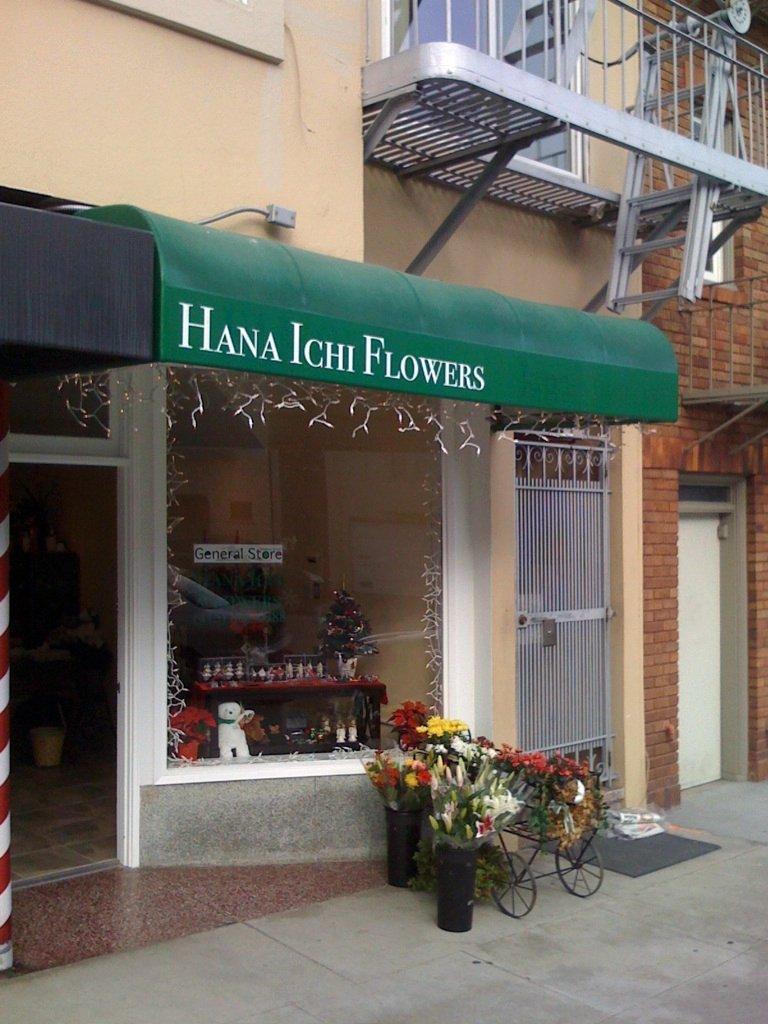Describe this image in one or two sentences. There are flower vases, which are having different color flowers, on the floor, near a shop, which is having a green color hoarding. In the shop, there are toys, flower buckeyes and bottles arranged on shelves. In the background, there is a gate of the building, which is having glass windows and there are other objects. 